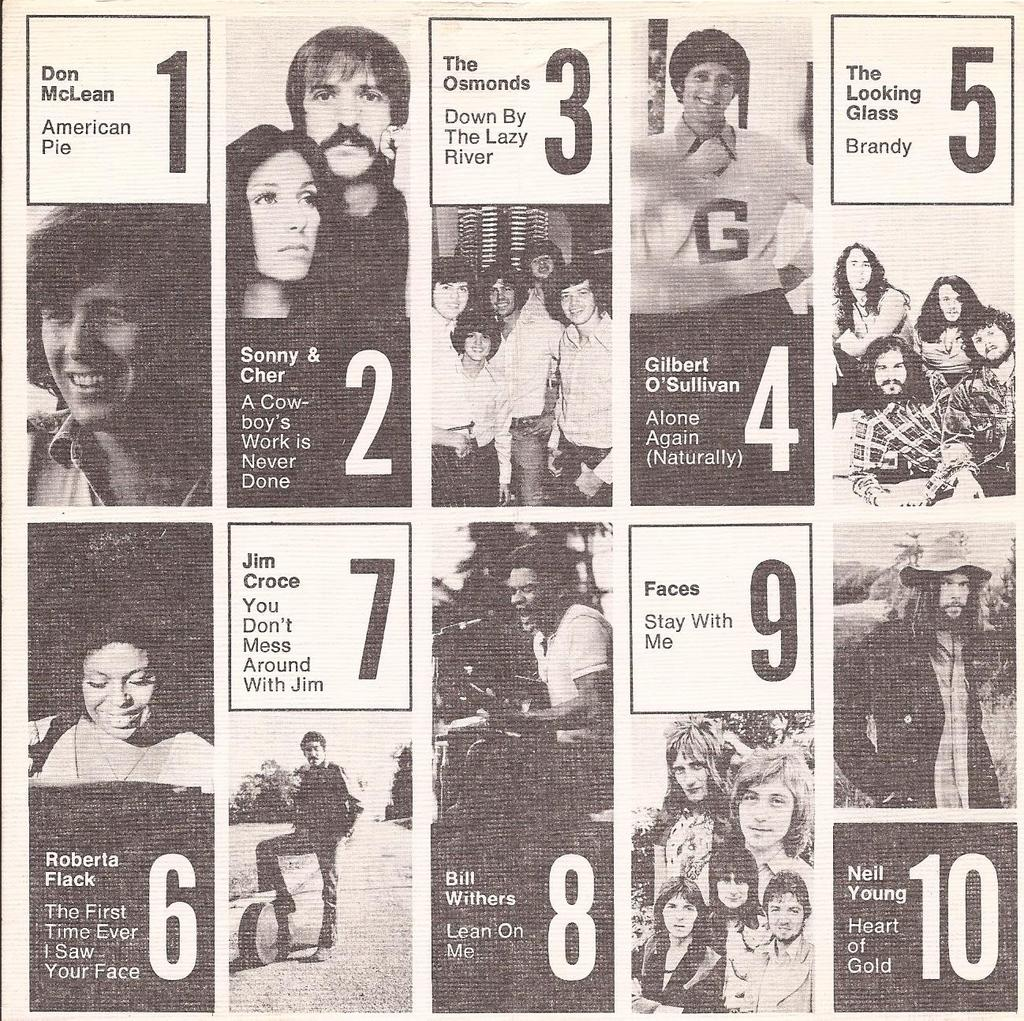What type of artwork is featured in the image? The image contains a collage of movie posters. Can you read any text on the movie posters? Yes, the title of a movie is printed on one of the posters. Are there any people depicted in the movie posters? Yes, a person is depicted on one of the posters. How many buildings are visible in the movie poster with the person? There are no buildings visible in the movie poster with the person, as the image only contains a collage of movie posters. 